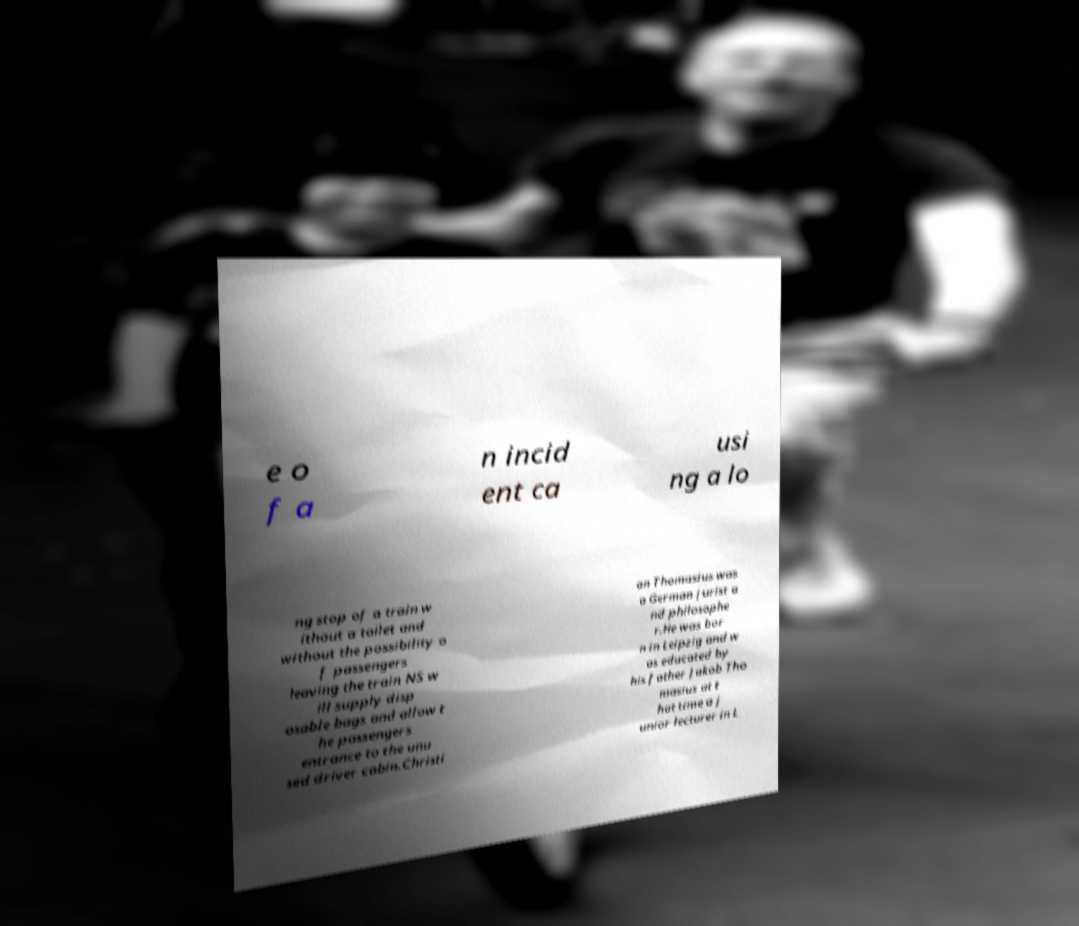Please read and relay the text visible in this image. What does it say? e o f a n incid ent ca usi ng a lo ng stop of a train w ithout a toilet and without the possibility o f passengers leaving the train NS w ill supply disp osable bags and allow t he passengers entrance to the unu sed driver cabin.Christi an Thomasius was a German jurist a nd philosophe r.He was bor n in Leipzig and w as educated by his father Jakob Tho masius at t hat time a j unior lecturer in L 